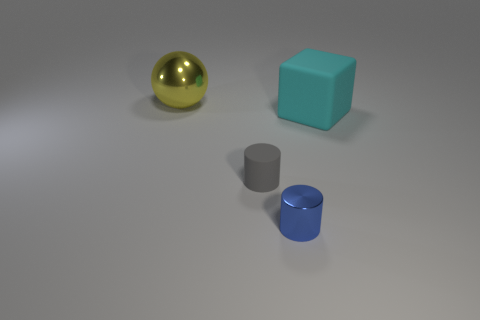Add 2 yellow matte things. How many objects exist? 6 Subtract all cubes. How many objects are left? 3 Add 1 big rubber cubes. How many big rubber cubes are left? 2 Add 3 small shiny cylinders. How many small shiny cylinders exist? 4 Subtract 0 green cylinders. How many objects are left? 4 Subtract all gray cylinders. Subtract all large red metal balls. How many objects are left? 3 